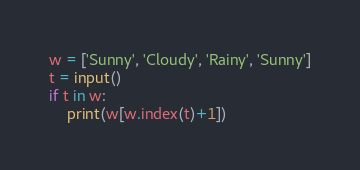Convert code to text. <code><loc_0><loc_0><loc_500><loc_500><_Python_>w = ['Sunny', 'Cloudy', 'Rainy', 'Sunny']
t = input()
if t in w:
    print(w[w.index(t)+1])</code> 